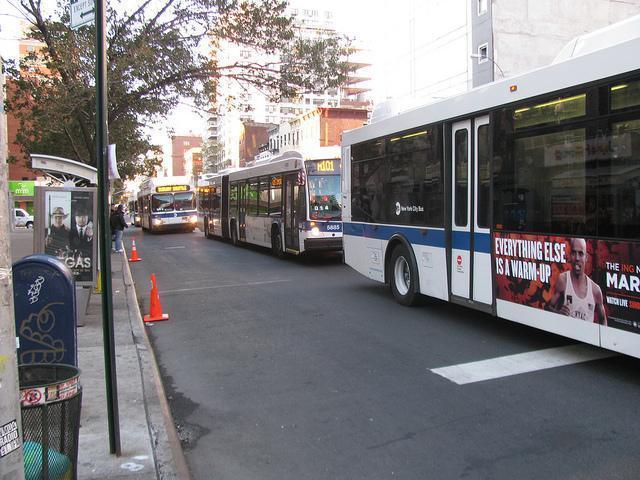How many buses are there?
Give a very brief answer. 3. How many buses can you see?
Give a very brief answer. 3. How many bicycles can you find in the image?
Give a very brief answer. 0. 